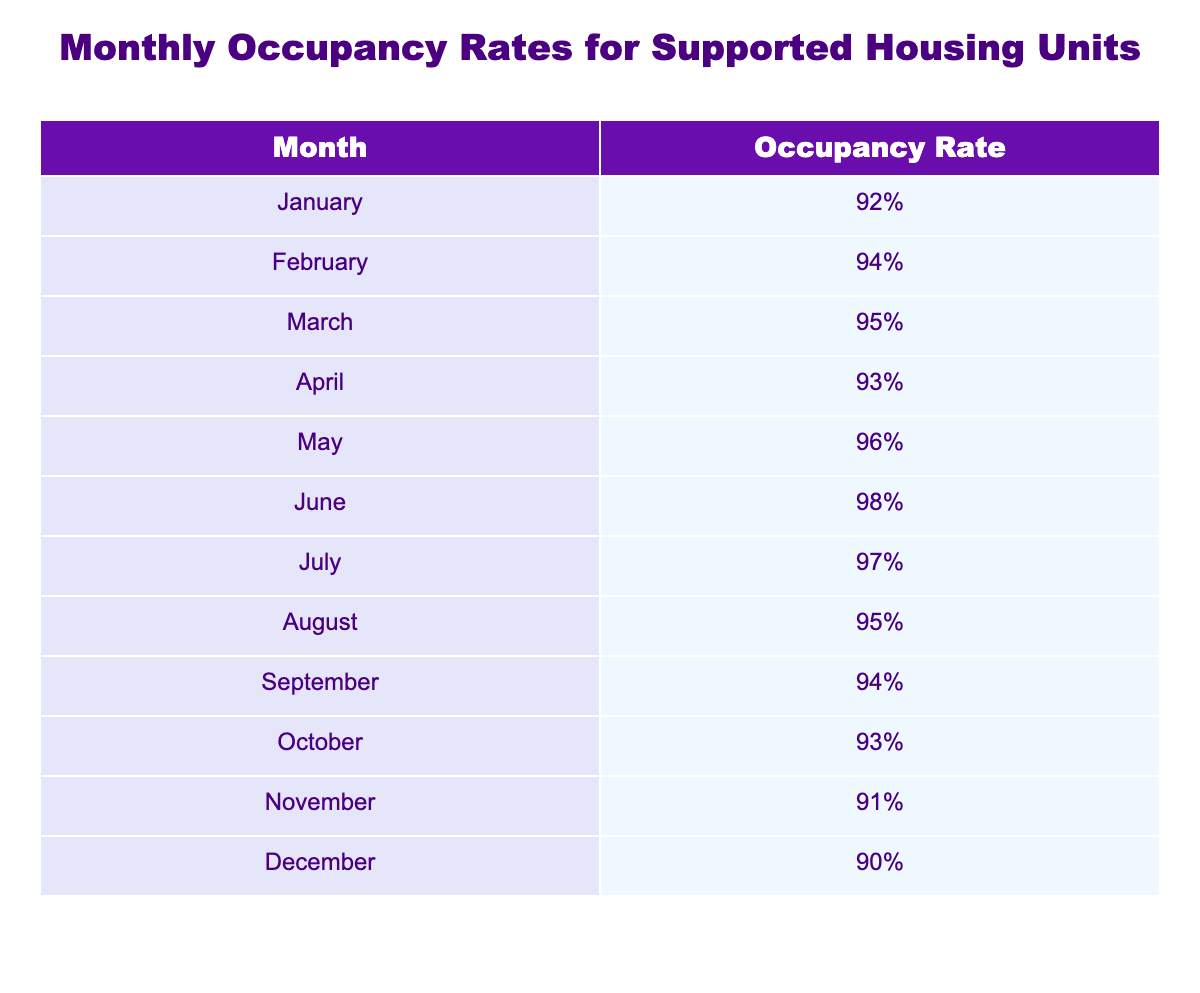What was the occupancy rate in June? The table shows a specific entry for June. Looking at the corresponding row, the occupancy rate in June is listed as 98%.
Answer: 98% What is the lowest occupancy rate recorded in the year? To find the lowest occupancy rate, we can look through all the values in the table. The lowest value is 90% in December.
Answer: 90% Which month had the highest occupancy rate? The highest occupancy rate can be determined by comparing all the monthly rates in the table. June has the highest recorded rate at 98%.
Answer: June What is the average occupancy rate for the second half of the year (July to December)? We first identify the occupancy rates from July to December: 97%, 95%, 94%, 93%, 91%, 90%. Summing these gives 97 + 95 + 94 + 93 + 91 + 90 = 560. There are 6 months, so the average is 560/6 = 93.33%.
Answer: 93.33% Did the occupancy rate increase from January to May? Analyzing the occupancy rates from January (92%) to May (96%), we can see the following: January (92%), February (94%), March (95%), April (93%), May (96%). The values show an increase from January's rate to February and March, a decrease in April, and then an increase again in May, indicating that there were fluctuations rather than a consistent increase.
Answer: No Which two consecutive months had the same occupancy rate? To find two consecutive months with the same occupancy rate, we review the month-to-month comparison. August and September both have a rate of 94%, indicating they are the same.
Answer: August and September What was the change in occupancy rate from November to December? Looking at the occupancy rates in November (91%) and December (90%), we find the change by subtracting December's rate from November's rate: 91% - 90% = 1%. So, the occupancy rate decreased by 1%.
Answer: Decrease of 1% Is the occupancy rate lower in December than in January? We compare the occupancy rates directly: December's rate is 90% and January's rate is 92%. Since 90% is less than 92%, we can conclude that December's rate is lower.
Answer: Yes What is the total occupancy rate for the first quarter (January to March)? We first gather the occupancy rates for January (92%), February (94%), and March (95%). Next, we sum these values: 92 + 94 + 95 = 281. There are three months, so the average is 281/3 = 93.67%.
Answer: 93.67% 